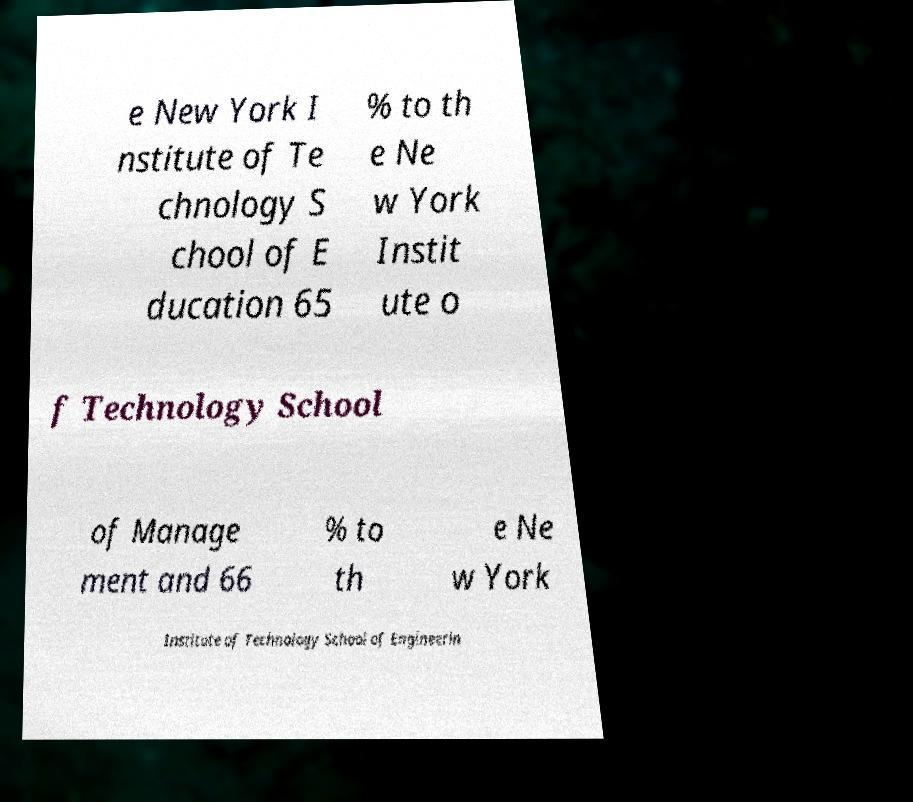I need the written content from this picture converted into text. Can you do that? e New York I nstitute of Te chnology S chool of E ducation 65 % to th e Ne w York Instit ute o f Technology School of Manage ment and 66 % to th e Ne w York Institute of Technology School of Engineerin 